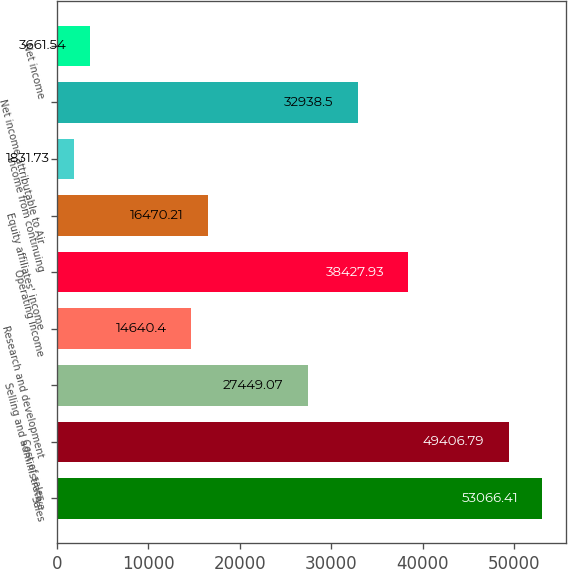<chart> <loc_0><loc_0><loc_500><loc_500><bar_chart><fcel>Sales<fcel>Cost of sales<fcel>Selling and administrative<fcel>Research and development<fcel>Operating Income<fcel>Equity affiliates' income<fcel>Income from continuing<fcel>Net income attributable to Air<fcel>Net income<nl><fcel>53066.4<fcel>49406.8<fcel>27449.1<fcel>14640.4<fcel>38427.9<fcel>16470.2<fcel>1831.73<fcel>32938.5<fcel>3661.54<nl></chart> 